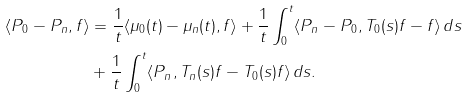Convert formula to latex. <formula><loc_0><loc_0><loc_500><loc_500>\langle P _ { 0 } - P _ { n } , f \rangle & = \frac { 1 } { t } \langle \mu _ { 0 } ( t ) - \mu _ { n } ( t ) , f \rangle + \frac { 1 } { t } \int _ { 0 } ^ { t } \langle P _ { n } - P _ { 0 } , T _ { 0 } ( s ) f - f \rangle \, d s \\ & + \frac { 1 } { t } \int _ { 0 } ^ { t } \langle P _ { n } , T _ { n } ( s ) f - T _ { 0 } ( s ) f \rangle \, d s .</formula> 